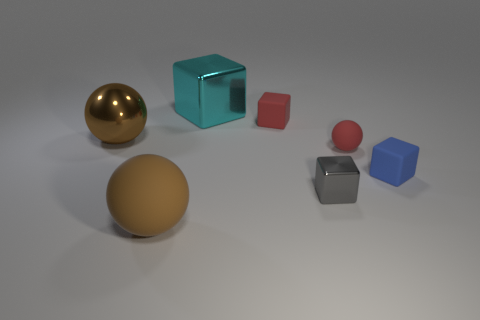Add 1 rubber balls. How many objects exist? 8 Subtract all blocks. How many objects are left? 3 Add 4 metal cubes. How many metal cubes are left? 6 Add 4 tiny red rubber blocks. How many tiny red rubber blocks exist? 5 Subtract 1 red spheres. How many objects are left? 6 Subtract all blue matte objects. Subtract all red balls. How many objects are left? 5 